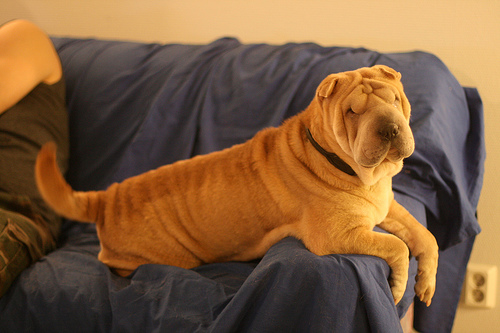Can you tell me more about the dog's surroundings? The dog is lounging on a blue sofa with a slightly rumpled cover that gives it a comfy, lived-in look. The lighting suggests an indoor setting, probably in a home environment. Does the room have any other noticeable features? While the dog is the main focus, you can observe a muted wall in the background. There's not much else visible to draw conclusions about other features of the room. 